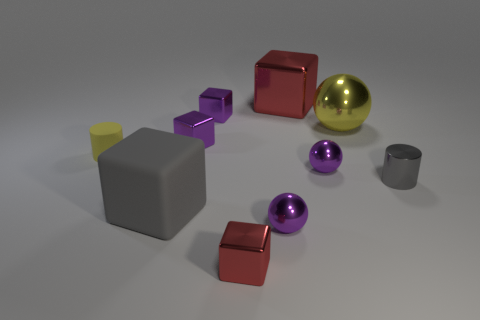Are there any reflective surfaces present in the objects shown? Yes, among the objects, the large golden sphere and the purple spheres exhibit highly reflective surfaces, creating subtle reflections of the environment and other objects. 